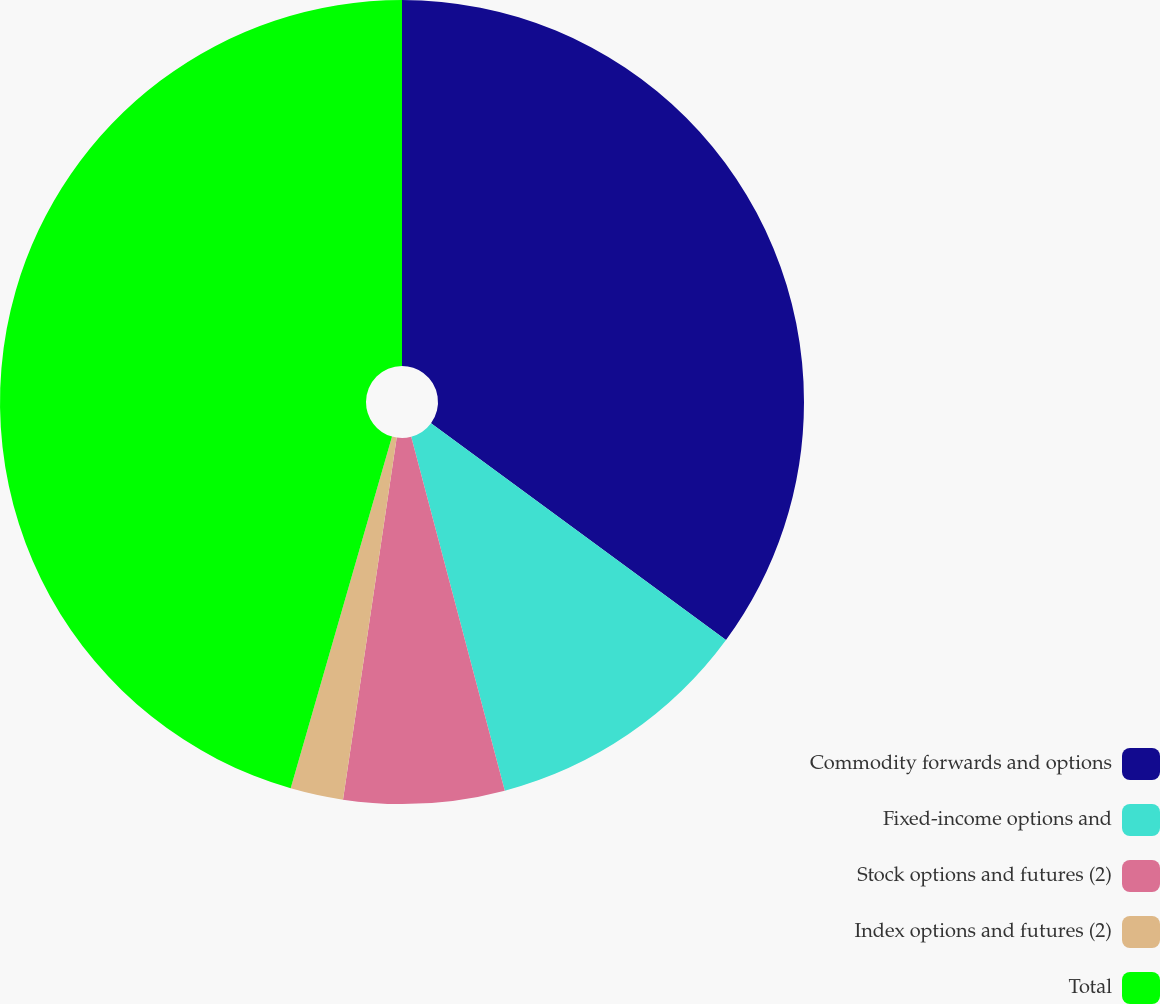<chart> <loc_0><loc_0><loc_500><loc_500><pie_chart><fcel>Commodity forwards and options<fcel>Fixed-income options and<fcel>Stock options and futures (2)<fcel>Index options and futures (2)<fcel>Total<nl><fcel>35.08%<fcel>10.8%<fcel>6.46%<fcel>2.12%<fcel>45.53%<nl></chart> 